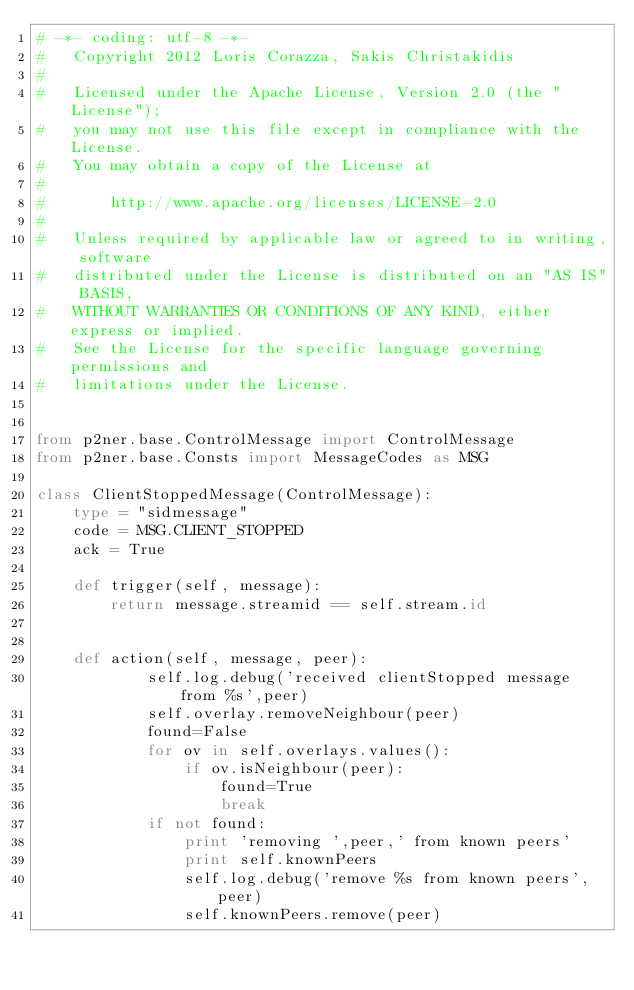Convert code to text. <code><loc_0><loc_0><loc_500><loc_500><_Python_># -*- coding: utf-8 -*-
#   Copyright 2012 Loris Corazza, Sakis Christakidis
#
#   Licensed under the Apache License, Version 2.0 (the "License");
#   you may not use this file except in compliance with the License.
#   You may obtain a copy of the License at
#
#       http://www.apache.org/licenses/LICENSE-2.0
#
#   Unless required by applicable law or agreed to in writing, software
#   distributed under the License is distributed on an "AS IS" BASIS,
#   WITHOUT WARRANTIES OR CONDITIONS OF ANY KIND, either express or implied.
#   See the License for the specific language governing permissions and
#   limitations under the License.


from p2ner.base.ControlMessage import ControlMessage
from p2ner.base.Consts import MessageCodes as MSG

class ClientStoppedMessage(ControlMessage):
    type = "sidmessage"
    code = MSG.CLIENT_STOPPED
    ack = True
    
    def trigger(self, message):
        return message.streamid == self.stream.id


    def action(self, message, peer):
            self.log.debug('received clientStopped message from %s',peer)
            self.overlay.removeNeighbour(peer)
            found=False
            for ov in self.overlays.values():
                if ov.isNeighbour(peer):
                    found=True
                    break
            if not found:
                print 'removing ',peer,' from known peers'
                print self.knownPeers
                self.log.debug('remove %s from known peers',peer)
                self.knownPeers.remove(peer)
</code> 